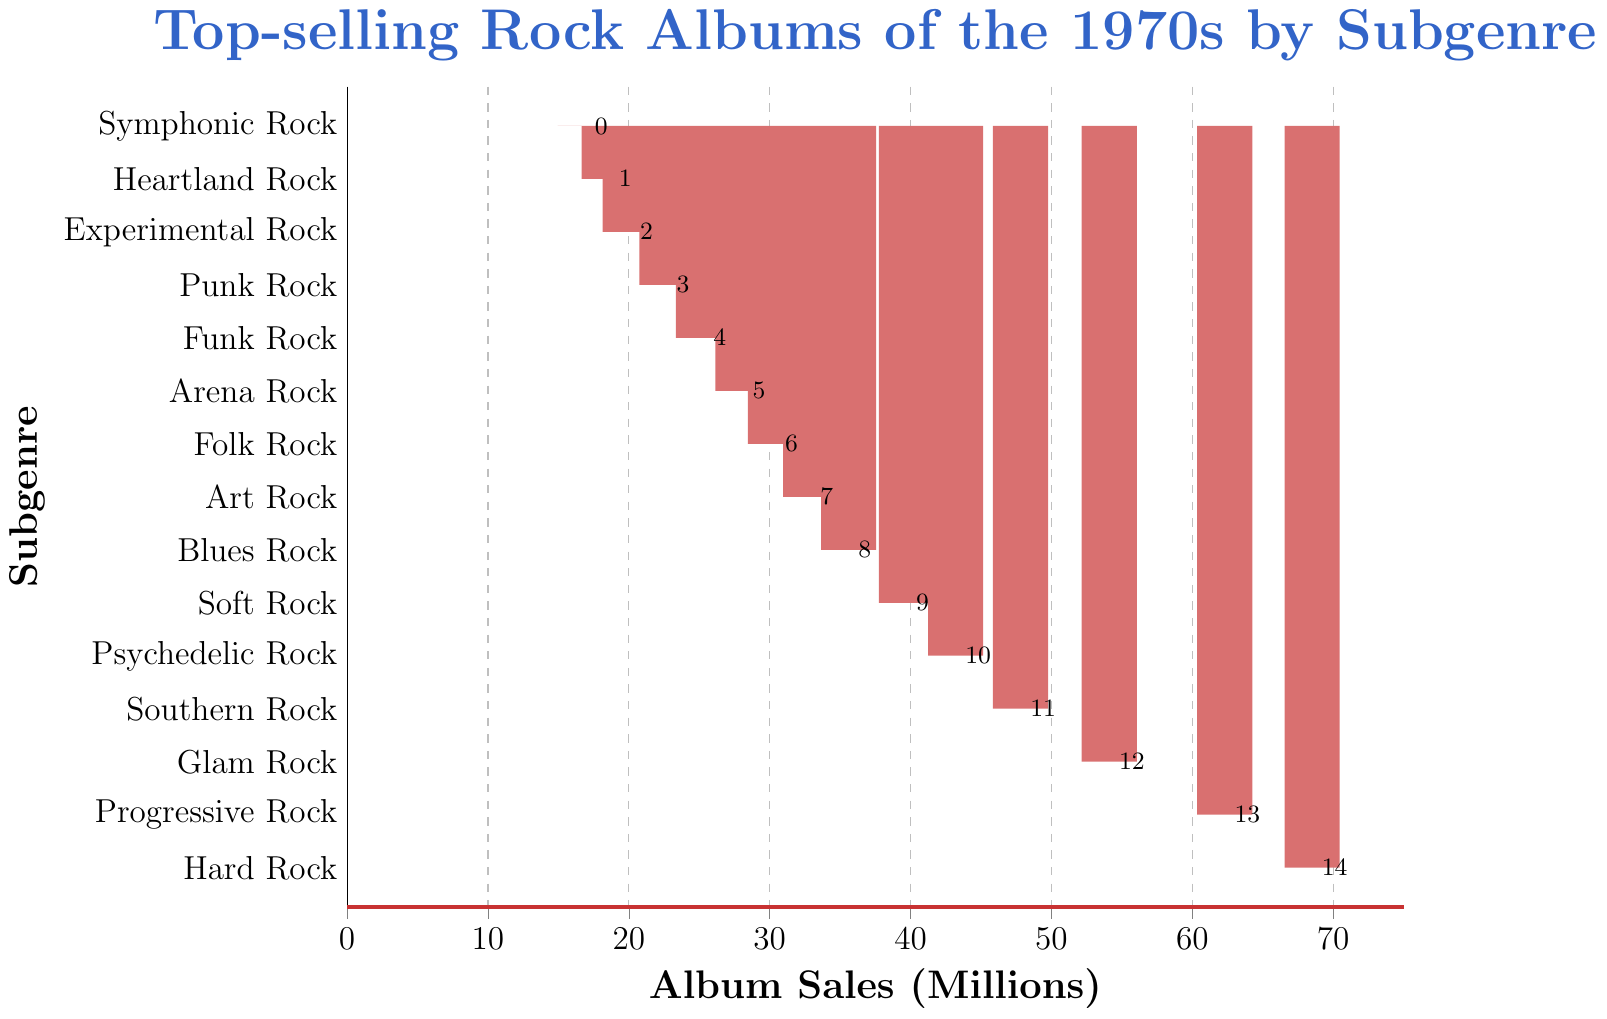What subgenre has the highest album sales in the 1970s? The bar representing Hard Rock is the tallest in the figure.
Answer: Hard Rock Which subgenre has the least album sales? The bar representing Symphonic Rock is the shortest in the figure.
Answer: Symphonic Rock How much higher is the album sales of Hard Rock compared to Punk Rock? The album sales for Hard Rock are 68.5 million, and for Punk Rock, they are 22.7 million. The difference is 68.5 - 22.7 = 45.8 million.
Answer: 45.8 million Are the album sales of Progressive Rock higher than those of Psychedelic Rock and Arena Rock combined? Progressive Rock has album sales of 62.3 million. Psychedelic Rock and Arena Rock combined have album sales of 43.2 + 28.1 = 71.3 million. Since 62.3 million < 71.3 million, Progressive Rock sales are not higher.
Answer: No What is the total album sales of the top three subgenres? The top three subgenres are Hard Rock (68.5 million), Progressive Rock (62.3 million), and Glam Rock (54.1 million). The total is 68.5 + 62.3 + 54.1 = 184.9 million.
Answer: 184.9 million Which subgenres have album sales between 30 and 40 million? The subgenres with sales between 30 and 40 million are Folk Rock (30.4 million), Art Rock (32.9 million), Blues Rock (35.6 million), and Soft Rock (39.7 million).
Answer: Folk Rock, Art Rock, Blues Rock, Soft Rock By how many millions do the album sales of Southern Rock exceed those of Funk Rock? Southern Rock album sales are 47.8 million and Funk Rock sales are 25.3 million. The difference is 47.8 - 25.3 = 22.5 million.
Answer: 22.5 million Which subgenres have more album sales than Arena Rock but less than Blues Rock? The subgenres that fit this criteria are Folk Rock (30.4 million) and Art Rock (32.9 million).
Answer: Folk Rock, Art Rock What are the combined album sales of the subgenres ranked from 10th to 15th? The subgenres ranked 10th to 15th are Psychedelic Rock (43.2 million), Soft Rock (39.7 million), Blues Rock (35.6 million), Art Rock (32.9 million), Folk Rock (30.4 million), and Arena Rock (28.1 million). The combined sales are 43.2 + 39.7 + 35.6 + 32.9 + 30.4 + 28.1 = 209.9 million.
Answer: 209.9 million Does the bar for Hard Rock have a different color than the other bars? The visual indicates that all bars are filled with the same color.
Answer: No 